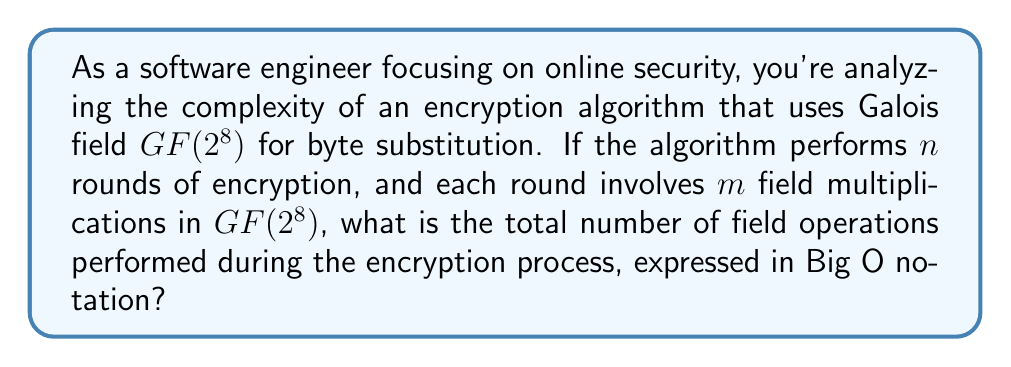Teach me how to tackle this problem. Let's break this down step-by-step:

1) In Galois field $GF(2^8)$, each element is represented by an 8-bit byte.

2) The algorithm performs $n$ rounds of encryption.

3) In each round, $m$ field multiplications are performed.

4) Therefore, the total number of field multiplications is $n \times m$.

5) In Big O notation, we're interested in the growth rate as the input size increases. Here, both $n$ and $m$ can be considered as input parameters.

6) The complexity is directly proportional to both $n$ and $m$.

7) In Big O notation, we express this as $O(nm)$.

This notation indicates that the time complexity grows linearly with both $n$ and $m$. As a software engineer looking for efficient solutions, you'd want to be aware of this complexity when implementing or recommending encryption algorithms, especially for large-scale applications where performance is crucial.
Answer: $O(nm)$ 